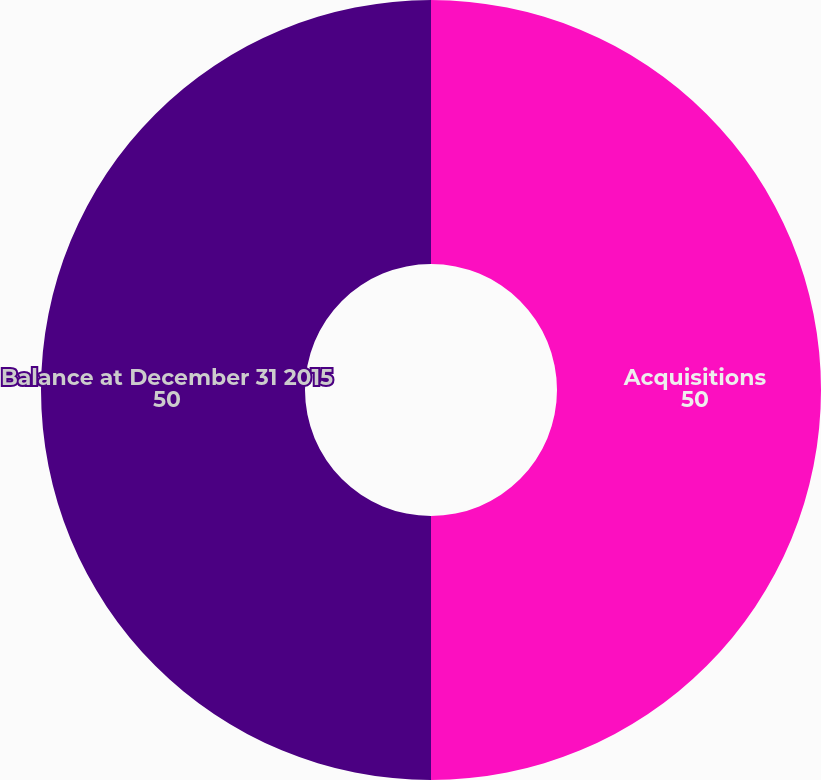<chart> <loc_0><loc_0><loc_500><loc_500><pie_chart><fcel>Acquisitions<fcel>Balance at December 31 2015<nl><fcel>50.0%<fcel>50.0%<nl></chart> 